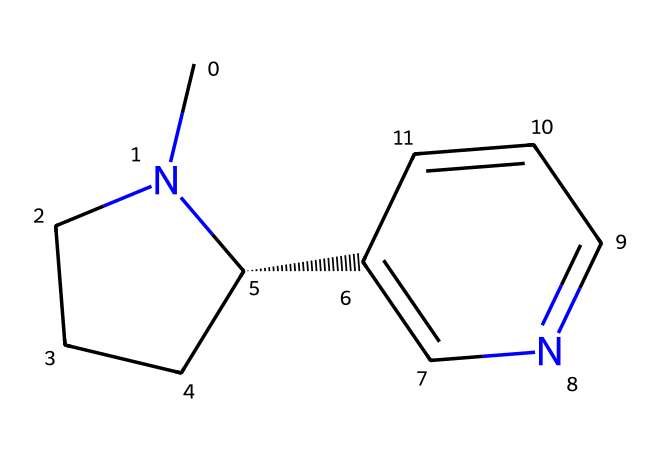What is the molecular formula of this chemical? To determine the molecular formula, we count the number of each type of atom represented in the SMILES. From the provided SMILES, we can see there are 10 carbons, 12 hydrogens, and 2 nitrogens. Therefore, the molecular formula is C10H12N2.
Answer: C10H12N2 How many rings are present in the structure? By analyzing the SMILES, we identify the presence of two numbered identifiers (1 and 2), indicating two distinct rings in the structure. Each number denotes a point where the ring closes.
Answer: 2 What type of compound is this? This chemical exhibits characteristics typical of alkaloids, such as containing nitrogen and having a biological activity profile. Thus, it can be classified as an alkaloid.
Answer: alkaloid Which atoms are responsible for the nitrogenous base structure? The nitrogen atoms (N) within this molecule are specifically connected to carbon structures that form the base. In the SMILES structure, there are 2 nitrogen atoms which classify it as nitrogenous.
Answer: nitrogen Does this compound contain any chiral centers? To assess chirality, we look for any carbon atoms bonded to four different substituents. Here, the chiral carbon is marked by the "@" symbol, confirming the presence of a chiral center in this compound.
Answer: yes How many hydrogen atoms are attached to the chiral carbon? By observing the chiral center in the SMILES representation, we note that it forms bonds with three other groups: a carbon and two hydrogen atoms. Thus, the chiral carbon has 2 hydrogen atoms attached to it.
Answer: 2 